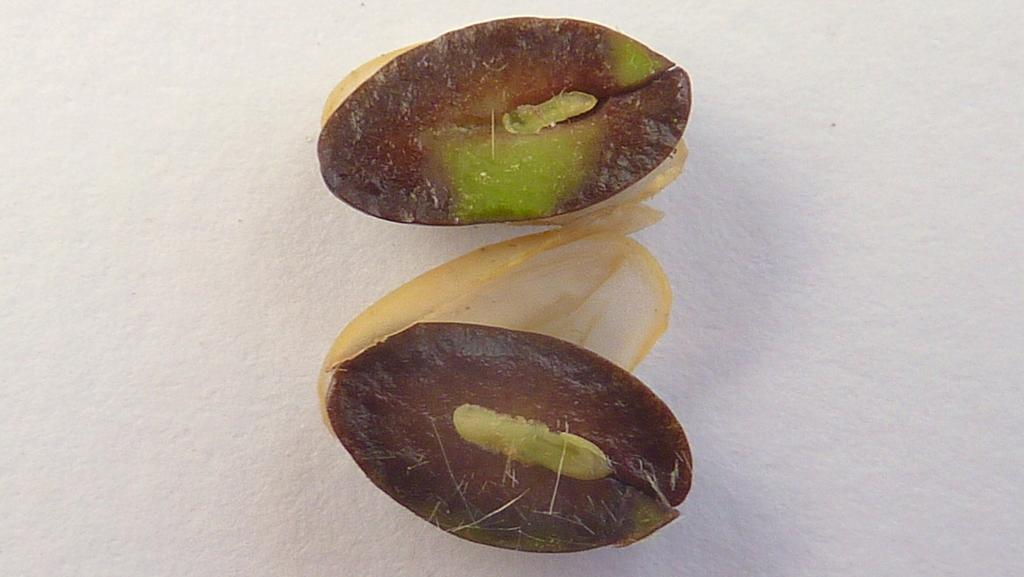How many sides are visible in the image? There are two sides visible in the image. What can be observed about the seeds in the image? The layers of the seeds are visible in the image. Can you hear the seeds laughing in the image? There is no sound or laughter present in the image, as it is a static visual representation. What type of toe is visible in the image? There is no toe present in the image; it features seeds with visible layers. 